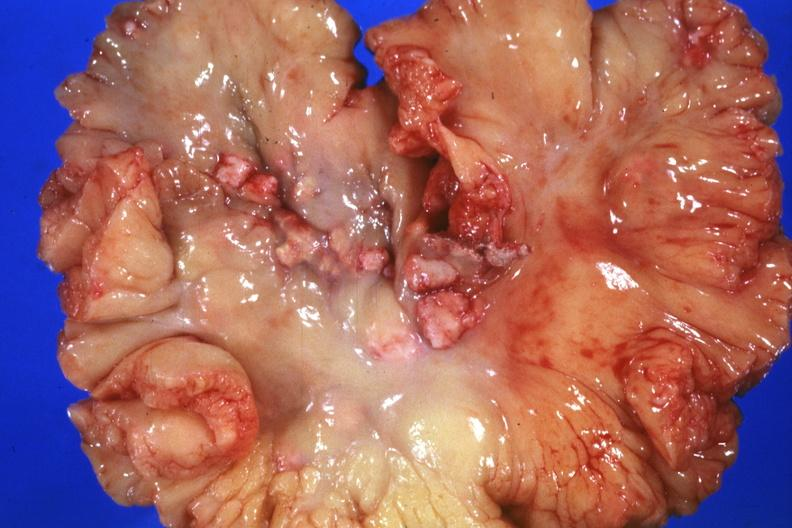how does this image show mesentery?
Answer the question using a single word or phrase. With involved nodes 